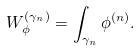Convert formula to latex. <formula><loc_0><loc_0><loc_500><loc_500>W ^ { ( \gamma _ { n } ) } _ { \phi } = \int _ { \gamma _ { n } } \phi ^ { ( n ) } .</formula> 